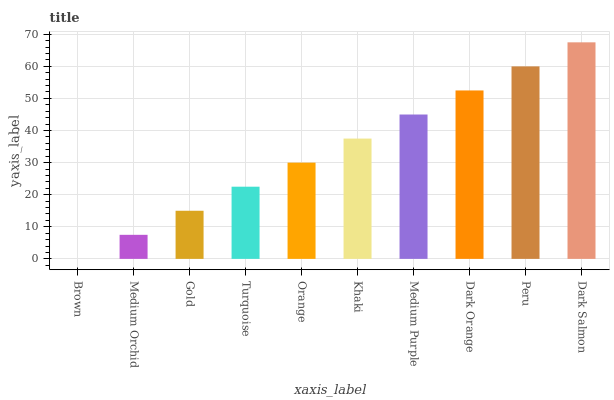Is Medium Orchid the minimum?
Answer yes or no. No. Is Medium Orchid the maximum?
Answer yes or no. No. Is Medium Orchid greater than Brown?
Answer yes or no. Yes. Is Brown less than Medium Orchid?
Answer yes or no. Yes. Is Brown greater than Medium Orchid?
Answer yes or no. No. Is Medium Orchid less than Brown?
Answer yes or no. No. Is Khaki the high median?
Answer yes or no. Yes. Is Orange the low median?
Answer yes or no. Yes. Is Peru the high median?
Answer yes or no. No. Is Dark Salmon the low median?
Answer yes or no. No. 